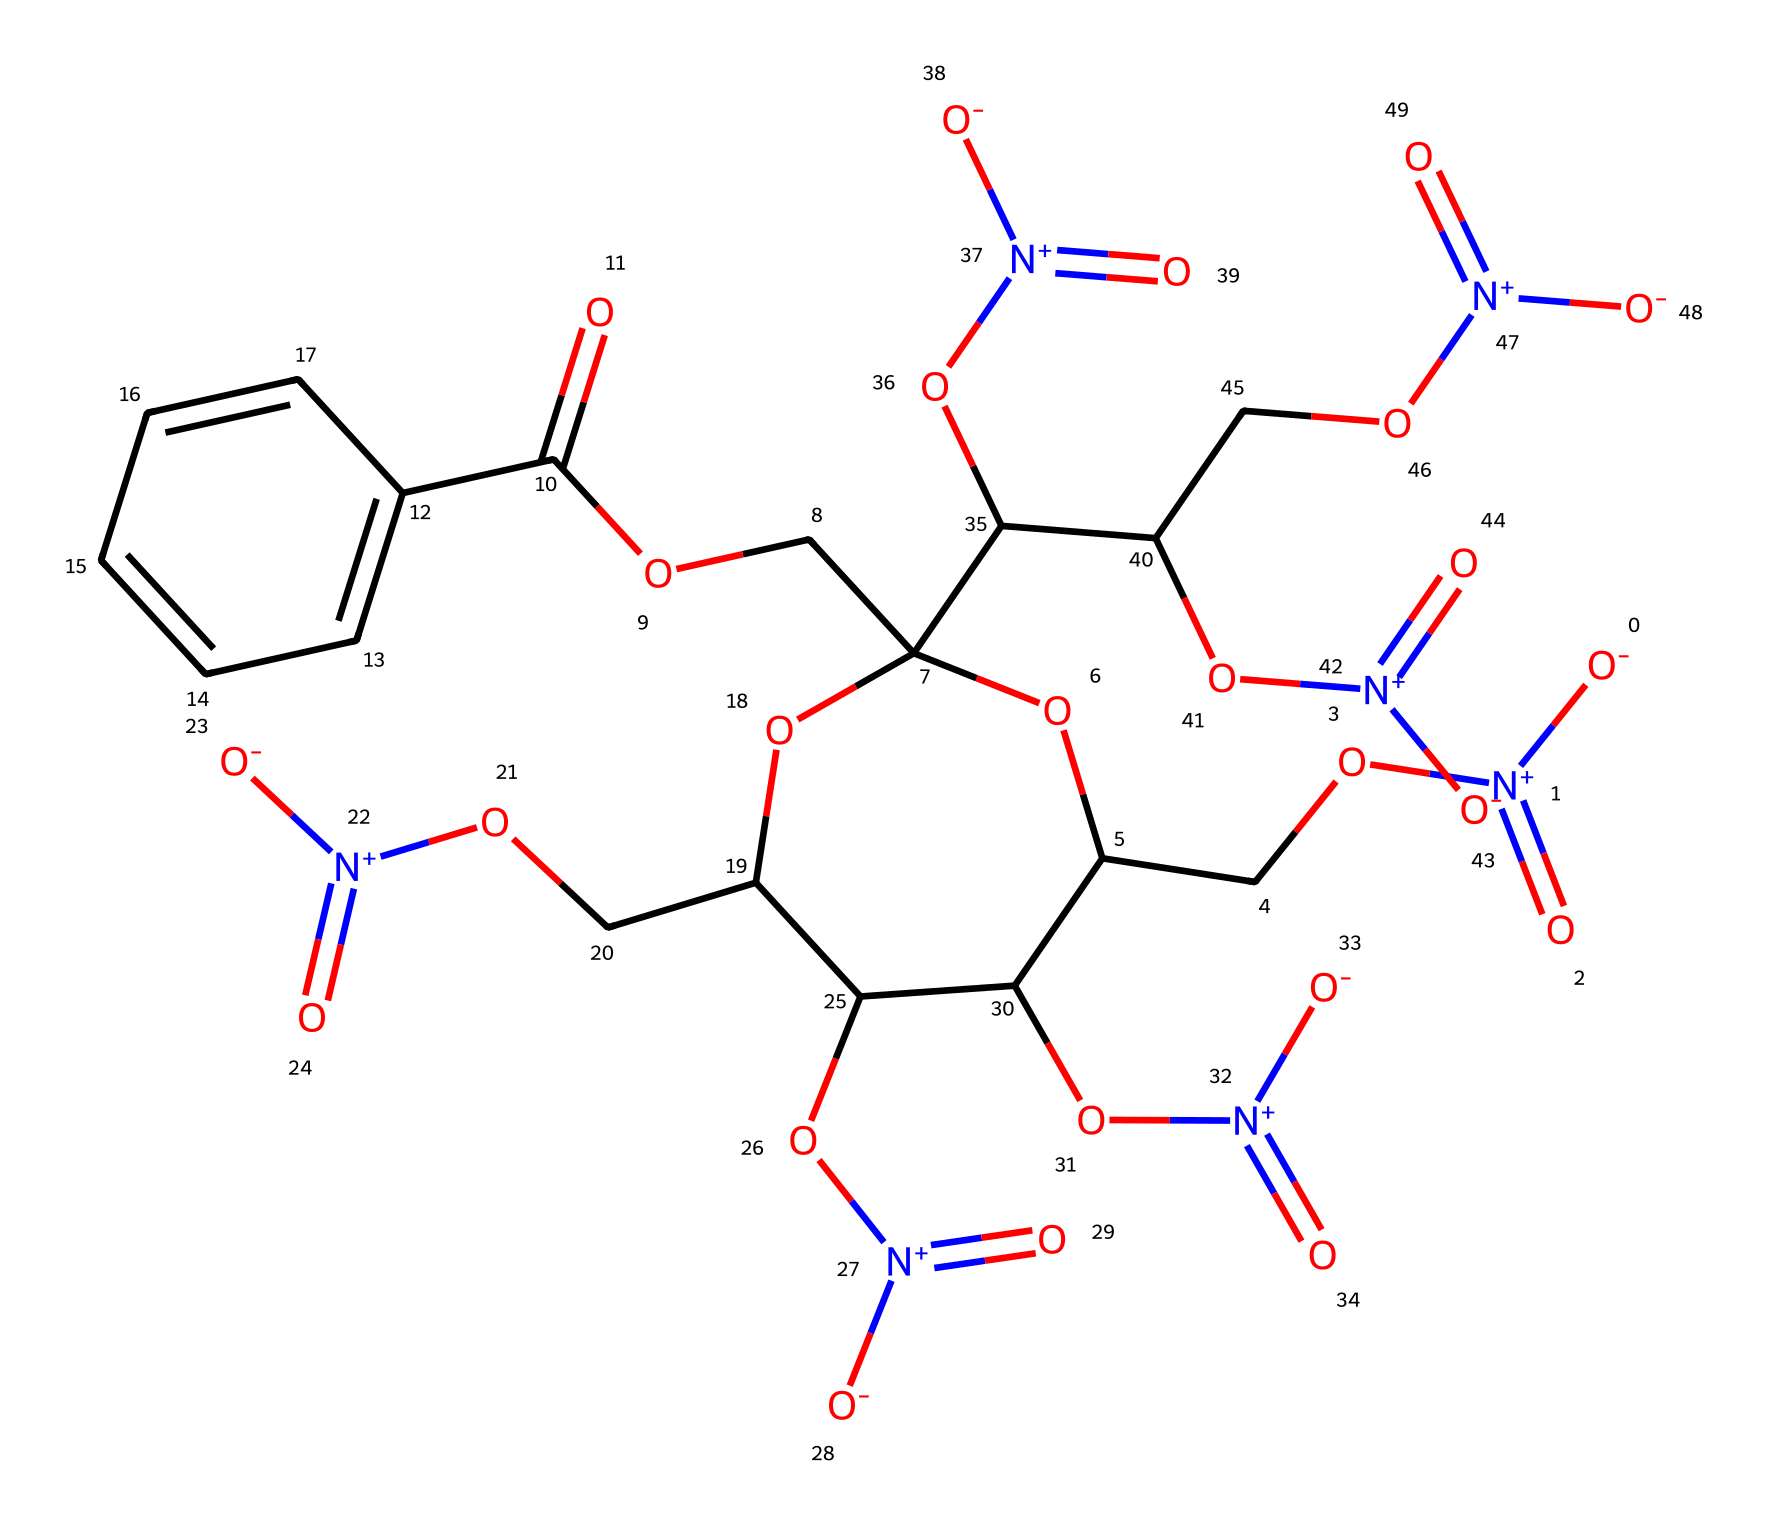What is the primary functional group present in nitrocellulose? The primary functional group in nitrocellulose is the nitro group, represented by the "-NO2" moiety, indicated in the SMILES with "[N+](=O)[O-]".
Answer: nitro group How many carbon atoms are in the structure of nitrocellulose? By analyzing the SMILES representation, we count the carbon atoms (C) indicated by the occurrences of 'C'. There are a total of 9 carbon atoms present in the molecule.
Answer: 9 What type of compound is nitrocellulose classified as? Nitrocellulose is classified as an organic nitrate, which is a type of explosive compound primarily used in smokeless powder. This classification stems from the presence of multiple nitrate functional groups within its structure.
Answer: organic nitrate How many nitro groups are attached to the nitrocellulose backbone? Examining the SMILES, we can identify four occurrences of the nitro group "[N+](=O)[O-]", which indicates there are four nitro groups attached to the molecule's backbone.
Answer: 4 What characteristic property does nitrocellulose contribute to smokeless powder? Nitrocellulose is known for its rapid combustion and high energy release, which significantly contributes to the propellant properties of smokeless powder. This characteristic arises from its structure that promotes efficient chemical reactions upon ignition.
Answer: rapid combustion What is the molecular formula for nitrocellulose derived from the SMILES? By translating the counts of each type of atom indicated in the SMILES, we derive the molecular formula C6H7N3O12, considering the representation of carbon (C), hydrogen (H), nitrogen (N), and oxygen (O) in the molecule.
Answer: C6H7N3O12 